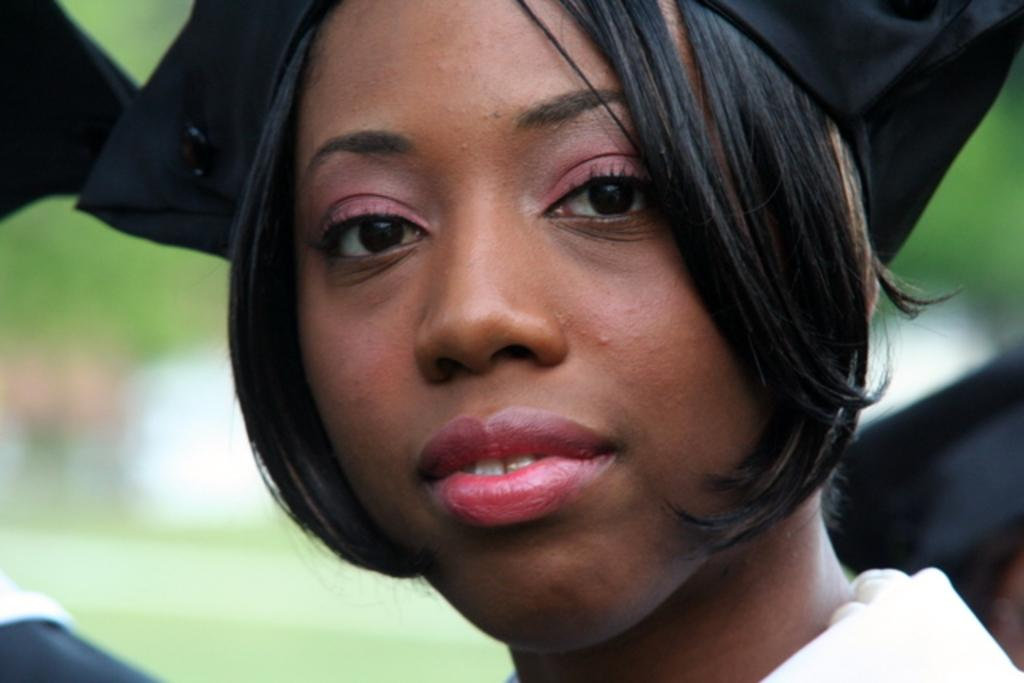What is the main subject of the image? The main subject of the image is a woman. Can you describe the woman's appearance in the image? The woman's face is visible in the image. What is on the woman's head in the image? There is an academic cap on the woman's head. How many balloons are tied to the woman's wrist in the image? There are no balloons visible in the image. Can you see any rabbits in the image? There are no rabbits present in the image. What type of heart-shaped object is visible in the image? There is no heart-shaped object present in the image. 